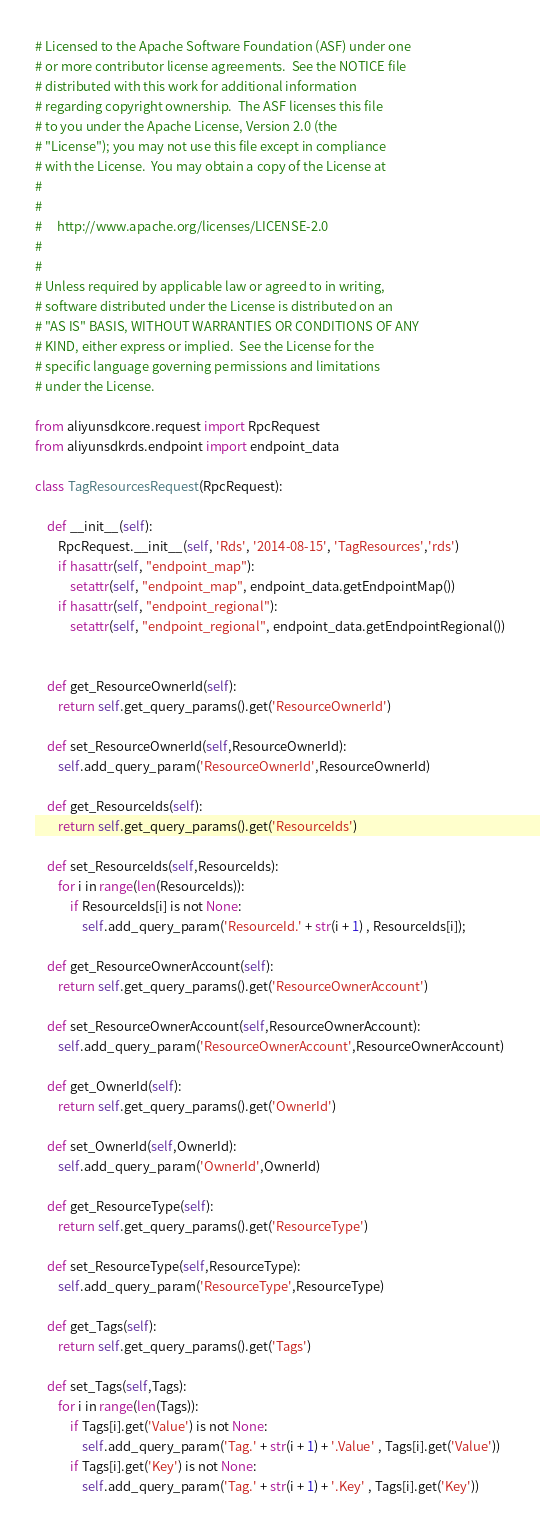<code> <loc_0><loc_0><loc_500><loc_500><_Python_># Licensed to the Apache Software Foundation (ASF) under one
# or more contributor license agreements.  See the NOTICE file
# distributed with this work for additional information
# regarding copyright ownership.  The ASF licenses this file
# to you under the Apache License, Version 2.0 (the
# "License"); you may not use this file except in compliance
# with the License.  You may obtain a copy of the License at
#
#
#     http://www.apache.org/licenses/LICENSE-2.0
#
#
# Unless required by applicable law or agreed to in writing,
# software distributed under the License is distributed on an
# "AS IS" BASIS, WITHOUT WARRANTIES OR CONDITIONS OF ANY
# KIND, either express or implied.  See the License for the
# specific language governing permissions and limitations
# under the License.

from aliyunsdkcore.request import RpcRequest
from aliyunsdkrds.endpoint import endpoint_data

class TagResourcesRequest(RpcRequest):

	def __init__(self):
		RpcRequest.__init__(self, 'Rds', '2014-08-15', 'TagResources','rds')
		if hasattr(self, "endpoint_map"):
			setattr(self, "endpoint_map", endpoint_data.getEndpointMap())
		if hasattr(self, "endpoint_regional"):
			setattr(self, "endpoint_regional", endpoint_data.getEndpointRegional())


	def get_ResourceOwnerId(self):
		return self.get_query_params().get('ResourceOwnerId')

	def set_ResourceOwnerId(self,ResourceOwnerId):
		self.add_query_param('ResourceOwnerId',ResourceOwnerId)

	def get_ResourceIds(self):
		return self.get_query_params().get('ResourceIds')

	def set_ResourceIds(self,ResourceIds):
		for i in range(len(ResourceIds)):	
			if ResourceIds[i] is not None:
				self.add_query_param('ResourceId.' + str(i + 1) , ResourceIds[i]);

	def get_ResourceOwnerAccount(self):
		return self.get_query_params().get('ResourceOwnerAccount')

	def set_ResourceOwnerAccount(self,ResourceOwnerAccount):
		self.add_query_param('ResourceOwnerAccount',ResourceOwnerAccount)

	def get_OwnerId(self):
		return self.get_query_params().get('OwnerId')

	def set_OwnerId(self,OwnerId):
		self.add_query_param('OwnerId',OwnerId)

	def get_ResourceType(self):
		return self.get_query_params().get('ResourceType')

	def set_ResourceType(self,ResourceType):
		self.add_query_param('ResourceType',ResourceType)

	def get_Tags(self):
		return self.get_query_params().get('Tags')

	def set_Tags(self,Tags):
		for i in range(len(Tags)):	
			if Tags[i].get('Value') is not None:
				self.add_query_param('Tag.' + str(i + 1) + '.Value' , Tags[i].get('Value'))
			if Tags[i].get('Key') is not None:
				self.add_query_param('Tag.' + str(i + 1) + '.Key' , Tags[i].get('Key'))
</code> 